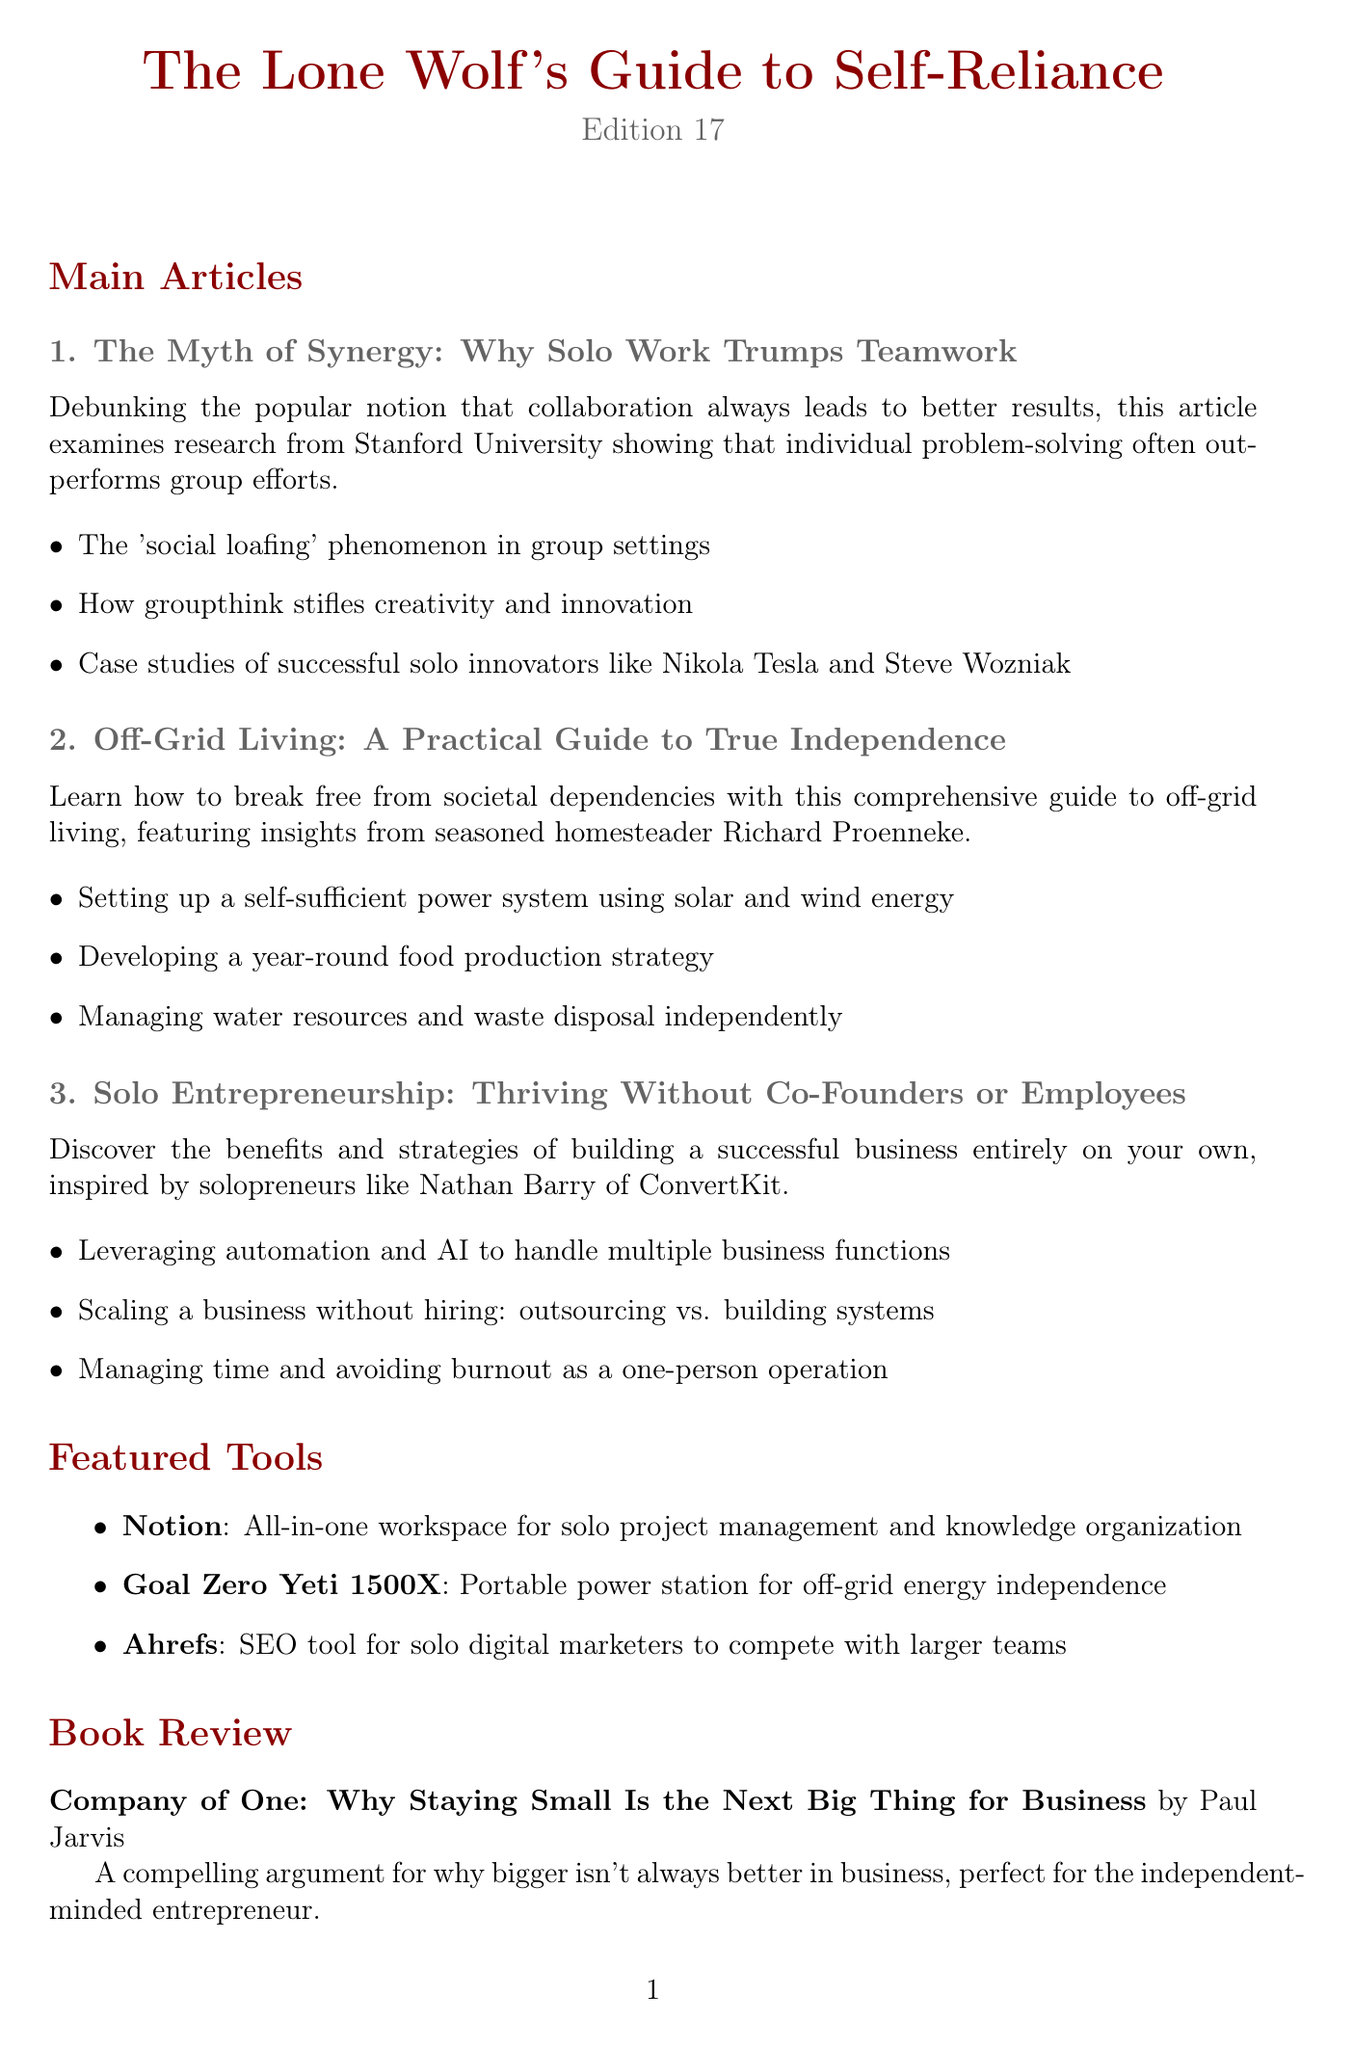What is the title of the newsletter? The title is specified at the beginning of the document.
Answer: The Lone Wolf's Guide to Self-Reliance What is the edition number of this newsletter? The edition number is mentioned in the header section of the document.
Answer: 17 Who is the author of the book reviewed? The author’s name is included in the book review section.
Answer: Paul Jarvis What is the date of the upcoming event mentioned? The event date is listed in the upcoming events section.
Answer: August 15-17, 2023 What myth is debunked in this edition? The myth debunked is stated in the "Myth Debunked" section.
Answer: You need a large network to succeed in business Which article discusses solo entrepreneurship? The article titles indicate which one covers this topic.
Answer: Solo Entrepreneurship: Thriving Without Co-Founders or Employees What tool is described as a portable power station? The featured tools section lists descriptions of each tool.
Answer: Goal Zero Yeti 1500X Who is featured as an inspiration for solo entrepreneurs? The name is mentioned in the article about solo entrepreneurship.
Answer: Nathan Barry 